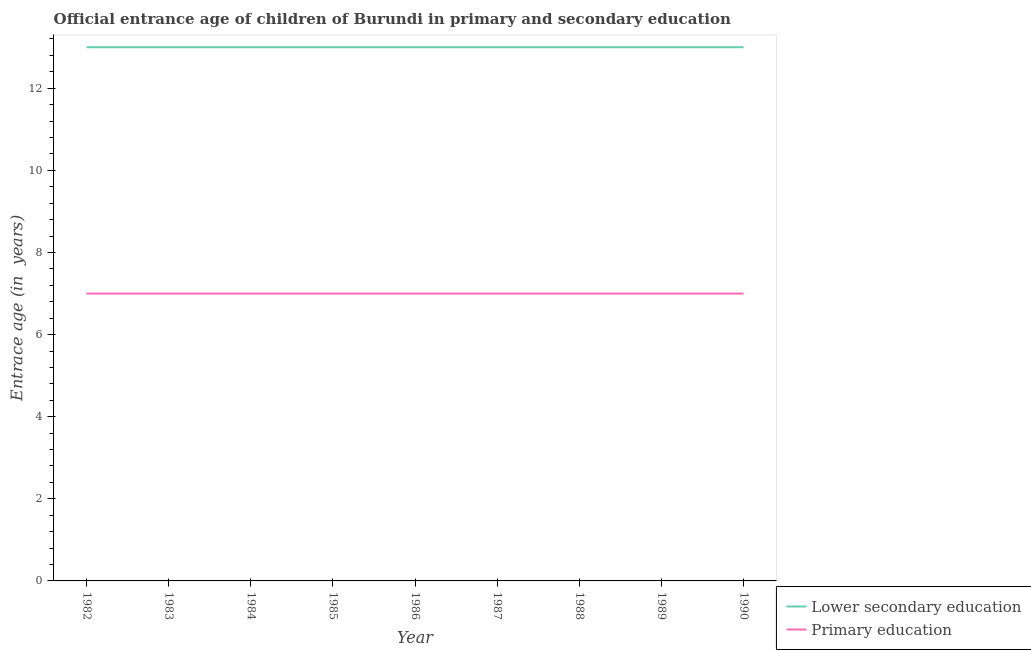Does the line corresponding to entrance age of chiildren in primary education intersect with the line corresponding to entrance age of children in lower secondary education?
Make the answer very short. No. What is the entrance age of chiildren in primary education in 1989?
Offer a terse response. 7. Across all years, what is the maximum entrance age of chiildren in primary education?
Your answer should be compact. 7. Across all years, what is the minimum entrance age of chiildren in primary education?
Your answer should be very brief. 7. In which year was the entrance age of children in lower secondary education maximum?
Provide a succinct answer. 1982. What is the total entrance age of chiildren in primary education in the graph?
Offer a terse response. 63. What is the difference between the entrance age of children in lower secondary education in 1985 and that in 1990?
Ensure brevity in your answer.  0. What is the difference between the entrance age of chiildren in primary education in 1988 and the entrance age of children in lower secondary education in 1983?
Keep it short and to the point. -6. In the year 1983, what is the difference between the entrance age of chiildren in primary education and entrance age of children in lower secondary education?
Provide a short and direct response. -6. What is the ratio of the entrance age of children in lower secondary education in 1988 to that in 1989?
Your answer should be compact. 1. Is the entrance age of children in lower secondary education in 1984 less than that in 1987?
Provide a short and direct response. No. Is the difference between the entrance age of children in lower secondary education in 1985 and 1989 greater than the difference between the entrance age of chiildren in primary education in 1985 and 1989?
Provide a succinct answer. No. What is the difference between the highest and the second highest entrance age of chiildren in primary education?
Your response must be concise. 0. Does the entrance age of children in lower secondary education monotonically increase over the years?
Your response must be concise. No. How many lines are there?
Offer a very short reply. 2. Are the values on the major ticks of Y-axis written in scientific E-notation?
Your answer should be compact. No. Where does the legend appear in the graph?
Make the answer very short. Bottom right. How many legend labels are there?
Give a very brief answer. 2. What is the title of the graph?
Provide a succinct answer. Official entrance age of children of Burundi in primary and secondary education. Does "GDP per capita" appear as one of the legend labels in the graph?
Ensure brevity in your answer.  No. What is the label or title of the Y-axis?
Your answer should be very brief. Entrace age (in  years). What is the Entrace age (in  years) in Lower secondary education in 1982?
Your answer should be compact. 13. What is the Entrace age (in  years) in Primary education in 1982?
Offer a very short reply. 7. What is the Entrace age (in  years) of Primary education in 1983?
Your answer should be very brief. 7. What is the Entrace age (in  years) of Lower secondary education in 1984?
Provide a short and direct response. 13. What is the Entrace age (in  years) of Lower secondary education in 1985?
Offer a terse response. 13. What is the Entrace age (in  years) in Primary education in 1985?
Provide a succinct answer. 7. What is the Entrace age (in  years) of Primary education in 1986?
Provide a short and direct response. 7. What is the Entrace age (in  years) in Primary education in 1987?
Provide a succinct answer. 7. What is the Entrace age (in  years) of Lower secondary education in 1988?
Make the answer very short. 13. What is the Entrace age (in  years) in Primary education in 1989?
Give a very brief answer. 7. What is the Entrace age (in  years) in Primary education in 1990?
Provide a succinct answer. 7. Across all years, what is the maximum Entrace age (in  years) of Primary education?
Your answer should be very brief. 7. What is the total Entrace age (in  years) in Lower secondary education in the graph?
Provide a short and direct response. 117. What is the difference between the Entrace age (in  years) of Lower secondary education in 1982 and that in 1983?
Provide a succinct answer. 0. What is the difference between the Entrace age (in  years) in Primary education in 1982 and that in 1984?
Keep it short and to the point. 0. What is the difference between the Entrace age (in  years) in Lower secondary education in 1982 and that in 1985?
Give a very brief answer. 0. What is the difference between the Entrace age (in  years) in Lower secondary education in 1982 and that in 1986?
Make the answer very short. 0. What is the difference between the Entrace age (in  years) of Primary education in 1982 and that in 1986?
Provide a short and direct response. 0. What is the difference between the Entrace age (in  years) in Lower secondary education in 1982 and that in 1987?
Give a very brief answer. 0. What is the difference between the Entrace age (in  years) in Primary education in 1982 and that in 1987?
Make the answer very short. 0. What is the difference between the Entrace age (in  years) of Lower secondary education in 1982 and that in 1988?
Provide a succinct answer. 0. What is the difference between the Entrace age (in  years) in Primary education in 1982 and that in 1989?
Ensure brevity in your answer.  0. What is the difference between the Entrace age (in  years) of Lower secondary education in 1983 and that in 1984?
Your answer should be very brief. 0. What is the difference between the Entrace age (in  years) in Lower secondary education in 1983 and that in 1985?
Offer a terse response. 0. What is the difference between the Entrace age (in  years) of Primary education in 1983 and that in 1985?
Your answer should be very brief. 0. What is the difference between the Entrace age (in  years) in Lower secondary education in 1983 and that in 1986?
Provide a succinct answer. 0. What is the difference between the Entrace age (in  years) in Primary education in 1983 and that in 1986?
Keep it short and to the point. 0. What is the difference between the Entrace age (in  years) in Lower secondary education in 1983 and that in 1987?
Make the answer very short. 0. What is the difference between the Entrace age (in  years) of Primary education in 1983 and that in 1987?
Offer a very short reply. 0. What is the difference between the Entrace age (in  years) in Primary education in 1983 and that in 1988?
Your answer should be very brief. 0. What is the difference between the Entrace age (in  years) in Lower secondary education in 1983 and that in 1990?
Make the answer very short. 0. What is the difference between the Entrace age (in  years) of Primary education in 1983 and that in 1990?
Provide a short and direct response. 0. What is the difference between the Entrace age (in  years) in Primary education in 1984 and that in 1990?
Offer a terse response. 0. What is the difference between the Entrace age (in  years) of Lower secondary education in 1985 and that in 1986?
Provide a short and direct response. 0. What is the difference between the Entrace age (in  years) of Primary education in 1985 and that in 1986?
Your response must be concise. 0. What is the difference between the Entrace age (in  years) of Lower secondary education in 1985 and that in 1987?
Your answer should be compact. 0. What is the difference between the Entrace age (in  years) of Primary education in 1985 and that in 1987?
Ensure brevity in your answer.  0. What is the difference between the Entrace age (in  years) in Lower secondary education in 1985 and that in 1989?
Ensure brevity in your answer.  0. What is the difference between the Entrace age (in  years) in Primary education in 1985 and that in 1989?
Offer a terse response. 0. What is the difference between the Entrace age (in  years) of Primary education in 1985 and that in 1990?
Provide a short and direct response. 0. What is the difference between the Entrace age (in  years) of Lower secondary education in 1986 and that in 1988?
Keep it short and to the point. 0. What is the difference between the Entrace age (in  years) of Primary education in 1986 and that in 1988?
Your answer should be compact. 0. What is the difference between the Entrace age (in  years) of Lower secondary education in 1986 and that in 1989?
Ensure brevity in your answer.  0. What is the difference between the Entrace age (in  years) of Primary education in 1986 and that in 1989?
Keep it short and to the point. 0. What is the difference between the Entrace age (in  years) in Lower secondary education in 1986 and that in 1990?
Your answer should be compact. 0. What is the difference between the Entrace age (in  years) in Lower secondary education in 1987 and that in 1990?
Ensure brevity in your answer.  0. What is the difference between the Entrace age (in  years) of Primary education in 1987 and that in 1990?
Give a very brief answer. 0. What is the difference between the Entrace age (in  years) in Lower secondary education in 1988 and that in 1989?
Give a very brief answer. 0. What is the difference between the Entrace age (in  years) of Lower secondary education in 1989 and that in 1990?
Your answer should be very brief. 0. What is the difference between the Entrace age (in  years) of Primary education in 1989 and that in 1990?
Give a very brief answer. 0. What is the difference between the Entrace age (in  years) of Lower secondary education in 1982 and the Entrace age (in  years) of Primary education in 1983?
Make the answer very short. 6. What is the difference between the Entrace age (in  years) in Lower secondary education in 1982 and the Entrace age (in  years) in Primary education in 1989?
Make the answer very short. 6. What is the difference between the Entrace age (in  years) in Lower secondary education in 1983 and the Entrace age (in  years) in Primary education in 1984?
Offer a very short reply. 6. What is the difference between the Entrace age (in  years) of Lower secondary education in 1983 and the Entrace age (in  years) of Primary education in 1986?
Ensure brevity in your answer.  6. What is the difference between the Entrace age (in  years) of Lower secondary education in 1983 and the Entrace age (in  years) of Primary education in 1988?
Your response must be concise. 6. What is the difference between the Entrace age (in  years) of Lower secondary education in 1983 and the Entrace age (in  years) of Primary education in 1990?
Ensure brevity in your answer.  6. What is the difference between the Entrace age (in  years) in Lower secondary education in 1984 and the Entrace age (in  years) in Primary education in 1985?
Make the answer very short. 6. What is the difference between the Entrace age (in  years) of Lower secondary education in 1984 and the Entrace age (in  years) of Primary education in 1988?
Your response must be concise. 6. What is the difference between the Entrace age (in  years) of Lower secondary education in 1984 and the Entrace age (in  years) of Primary education in 1989?
Keep it short and to the point. 6. What is the difference between the Entrace age (in  years) of Lower secondary education in 1985 and the Entrace age (in  years) of Primary education in 1986?
Ensure brevity in your answer.  6. What is the difference between the Entrace age (in  years) in Lower secondary education in 1985 and the Entrace age (in  years) in Primary education in 1988?
Your response must be concise. 6. What is the difference between the Entrace age (in  years) of Lower secondary education in 1985 and the Entrace age (in  years) of Primary education in 1989?
Give a very brief answer. 6. What is the difference between the Entrace age (in  years) of Lower secondary education in 1986 and the Entrace age (in  years) of Primary education in 1987?
Provide a short and direct response. 6. What is the difference between the Entrace age (in  years) of Lower secondary education in 1987 and the Entrace age (in  years) of Primary education in 1988?
Offer a very short reply. 6. What is the difference between the Entrace age (in  years) in Lower secondary education in 1987 and the Entrace age (in  years) in Primary education in 1989?
Offer a terse response. 6. What is the average Entrace age (in  years) in Lower secondary education per year?
Ensure brevity in your answer.  13. In the year 1983, what is the difference between the Entrace age (in  years) of Lower secondary education and Entrace age (in  years) of Primary education?
Provide a succinct answer. 6. In the year 1985, what is the difference between the Entrace age (in  years) of Lower secondary education and Entrace age (in  years) of Primary education?
Your answer should be very brief. 6. In the year 1986, what is the difference between the Entrace age (in  years) in Lower secondary education and Entrace age (in  years) in Primary education?
Make the answer very short. 6. In the year 1988, what is the difference between the Entrace age (in  years) in Lower secondary education and Entrace age (in  years) in Primary education?
Keep it short and to the point. 6. In the year 1990, what is the difference between the Entrace age (in  years) in Lower secondary education and Entrace age (in  years) in Primary education?
Your answer should be compact. 6. What is the ratio of the Entrace age (in  years) of Lower secondary education in 1982 to that in 1983?
Your answer should be very brief. 1. What is the ratio of the Entrace age (in  years) in Lower secondary education in 1982 to that in 1984?
Give a very brief answer. 1. What is the ratio of the Entrace age (in  years) in Primary education in 1982 to that in 1985?
Your answer should be very brief. 1. What is the ratio of the Entrace age (in  years) of Lower secondary education in 1982 to that in 1986?
Keep it short and to the point. 1. What is the ratio of the Entrace age (in  years) of Primary education in 1982 to that in 1986?
Your answer should be compact. 1. What is the ratio of the Entrace age (in  years) in Lower secondary education in 1982 to that in 1989?
Provide a succinct answer. 1. What is the ratio of the Entrace age (in  years) in Lower secondary education in 1983 to that in 1984?
Provide a short and direct response. 1. What is the ratio of the Entrace age (in  years) of Primary education in 1983 to that in 1984?
Provide a succinct answer. 1. What is the ratio of the Entrace age (in  years) of Primary education in 1983 to that in 1985?
Keep it short and to the point. 1. What is the ratio of the Entrace age (in  years) of Primary education in 1983 to that in 1987?
Your answer should be compact. 1. What is the ratio of the Entrace age (in  years) in Primary education in 1983 to that in 1989?
Provide a succinct answer. 1. What is the ratio of the Entrace age (in  years) in Lower secondary education in 1983 to that in 1990?
Provide a short and direct response. 1. What is the ratio of the Entrace age (in  years) in Lower secondary education in 1984 to that in 1986?
Your answer should be compact. 1. What is the ratio of the Entrace age (in  years) of Primary education in 1984 to that in 1986?
Your answer should be very brief. 1. What is the ratio of the Entrace age (in  years) in Lower secondary education in 1984 to that in 1987?
Make the answer very short. 1. What is the ratio of the Entrace age (in  years) of Lower secondary education in 1984 to that in 1989?
Provide a succinct answer. 1. What is the ratio of the Entrace age (in  years) in Primary education in 1984 to that in 1989?
Keep it short and to the point. 1. What is the ratio of the Entrace age (in  years) of Primary education in 1984 to that in 1990?
Your answer should be very brief. 1. What is the ratio of the Entrace age (in  years) in Primary education in 1985 to that in 1986?
Your answer should be very brief. 1. What is the ratio of the Entrace age (in  years) in Primary education in 1985 to that in 1987?
Your answer should be compact. 1. What is the ratio of the Entrace age (in  years) in Lower secondary education in 1985 to that in 1988?
Offer a terse response. 1. What is the ratio of the Entrace age (in  years) in Primary education in 1985 to that in 1988?
Keep it short and to the point. 1. What is the ratio of the Entrace age (in  years) in Lower secondary education in 1985 to that in 1989?
Keep it short and to the point. 1. What is the ratio of the Entrace age (in  years) of Primary education in 1985 to that in 1990?
Provide a short and direct response. 1. What is the ratio of the Entrace age (in  years) in Primary education in 1986 to that in 1987?
Offer a terse response. 1. What is the ratio of the Entrace age (in  years) in Lower secondary education in 1986 to that in 1988?
Offer a terse response. 1. What is the ratio of the Entrace age (in  years) of Primary education in 1986 to that in 1988?
Offer a very short reply. 1. What is the ratio of the Entrace age (in  years) in Lower secondary education in 1986 to that in 1989?
Keep it short and to the point. 1. What is the ratio of the Entrace age (in  years) in Primary education in 1986 to that in 1989?
Your answer should be compact. 1. What is the ratio of the Entrace age (in  years) of Lower secondary education in 1986 to that in 1990?
Your answer should be compact. 1. What is the ratio of the Entrace age (in  years) of Lower secondary education in 1987 to that in 1988?
Give a very brief answer. 1. What is the ratio of the Entrace age (in  years) in Primary education in 1987 to that in 1988?
Give a very brief answer. 1. What is the ratio of the Entrace age (in  years) in Primary education in 1987 to that in 1989?
Ensure brevity in your answer.  1. What is the ratio of the Entrace age (in  years) of Lower secondary education in 1987 to that in 1990?
Provide a short and direct response. 1. What is the ratio of the Entrace age (in  years) of Primary education in 1987 to that in 1990?
Offer a very short reply. 1. What is the difference between the highest and the second highest Entrace age (in  years) in Primary education?
Your answer should be compact. 0. What is the difference between the highest and the lowest Entrace age (in  years) of Lower secondary education?
Offer a very short reply. 0. 